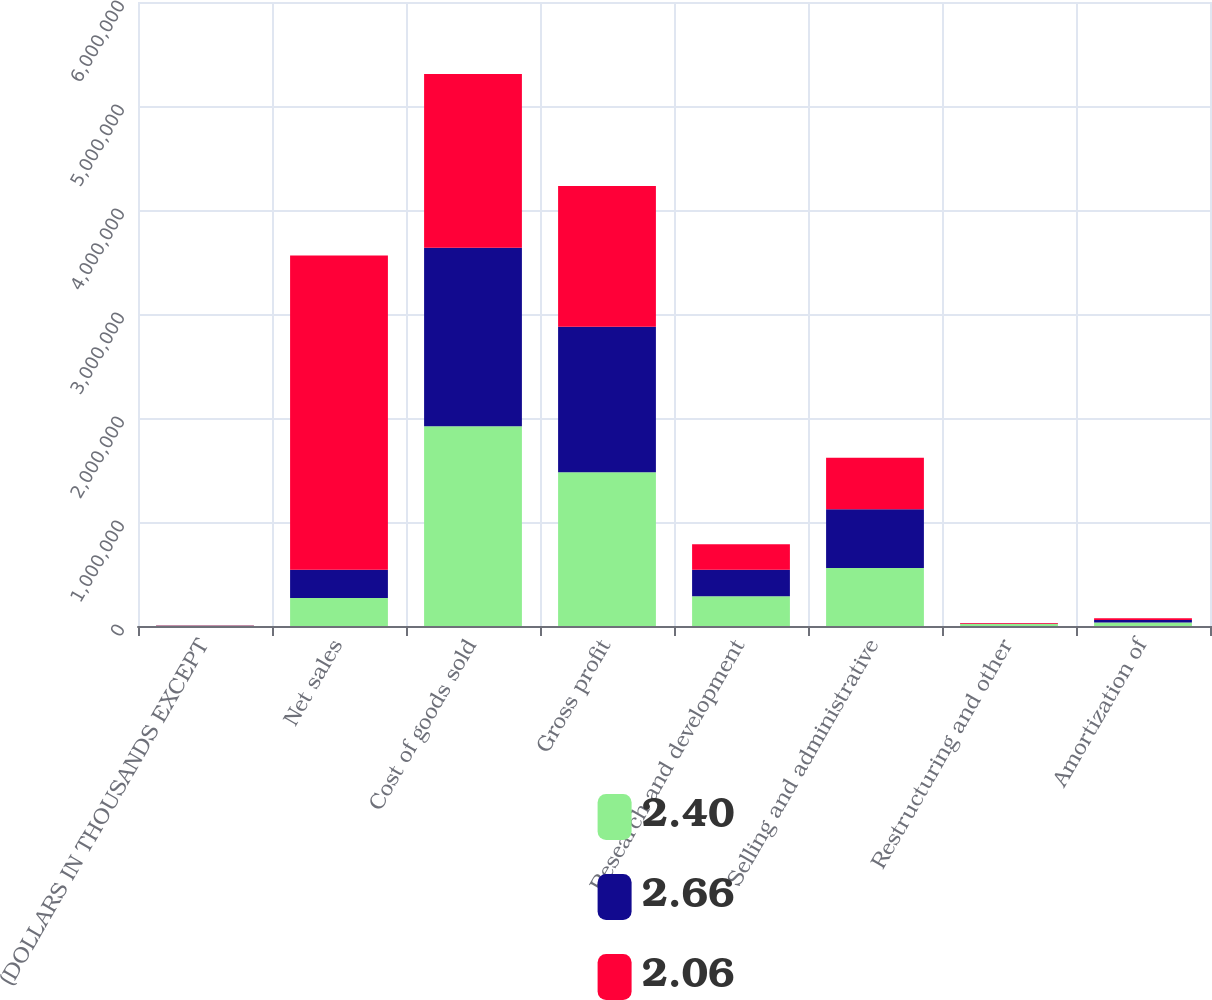Convert chart. <chart><loc_0><loc_0><loc_500><loc_500><stacked_bar_chart><ecel><fcel>(DOLLARS IN THOUSANDS EXCEPT<fcel>Net sales<fcel>Cost of goods sold<fcel>Gross profit<fcel>Research and development<fcel>Selling and administrative<fcel>Restructuring and other<fcel>Amortization of<nl><fcel>2.4<fcel>2017<fcel>270144<fcel>1.91972e+06<fcel>1.479e+06<fcel>286026<fcel>557311<fcel>19711<fcel>34694<nl><fcel>2.66<fcel>2016<fcel>270144<fcel>1.71728e+06<fcel>1.39907e+06<fcel>254263<fcel>566224<fcel>1700<fcel>23763<nl><fcel>2.06<fcel>2015<fcel>3.02319e+06<fcel>1.67159e+06<fcel>1.3516e+06<fcel>246101<fcel>494517<fcel>7594<fcel>15040<nl></chart> 